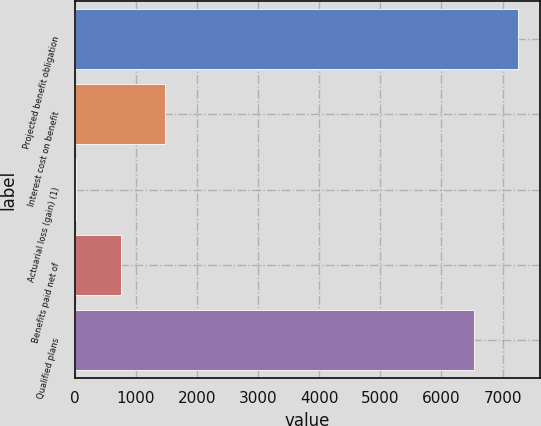Convert chart. <chart><loc_0><loc_0><loc_500><loc_500><bar_chart><fcel>Projected benefit obligation<fcel>Interest cost on benefit<fcel>Actuarial loss (gain) (1)<fcel>Benefits paid net of<fcel>Qualified plans<nl><fcel>7256.4<fcel>1472.8<fcel>28<fcel>750.4<fcel>6534<nl></chart> 